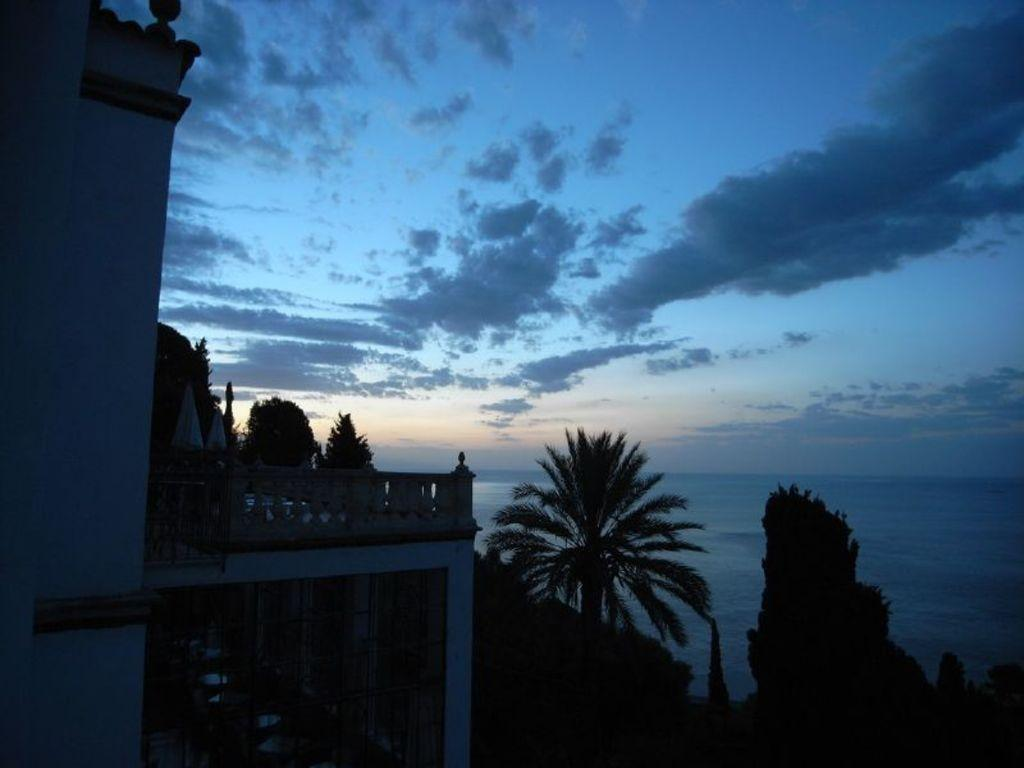What type of structure can be seen in the image? There is a building in the image. What other natural elements are present in the image? There are trees and the sea visible in the image. What can be seen in the background of the image? The sky is visible in the background of the image. What type of rice is being prepared on the floor in the image? There is no rice or floor present in the image; it features a building, trees, the sea, and the sky. 